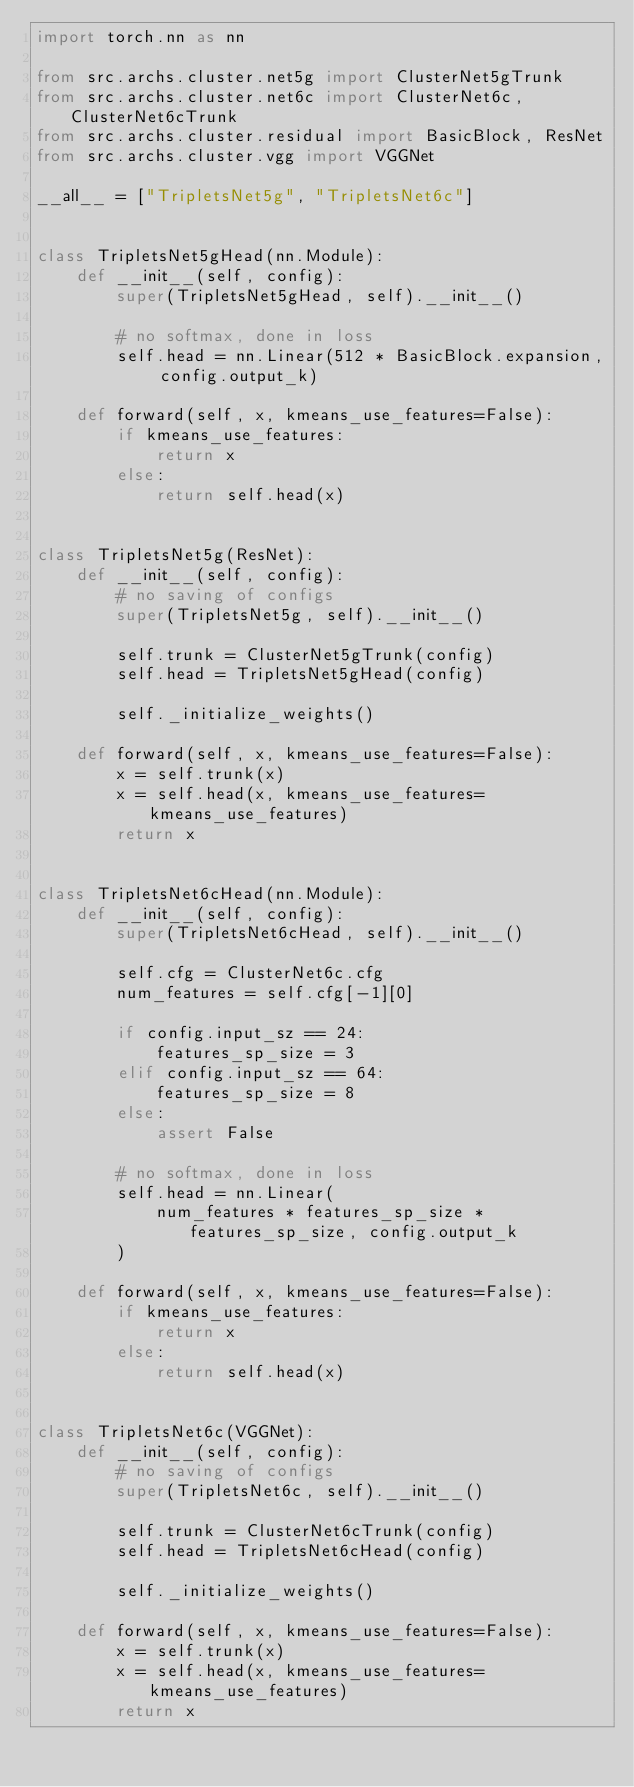Convert code to text. <code><loc_0><loc_0><loc_500><loc_500><_Python_>import torch.nn as nn

from src.archs.cluster.net5g import ClusterNet5gTrunk
from src.archs.cluster.net6c import ClusterNet6c, ClusterNet6cTrunk
from src.archs.cluster.residual import BasicBlock, ResNet
from src.archs.cluster.vgg import VGGNet

__all__ = ["TripletsNet5g", "TripletsNet6c"]


class TripletsNet5gHead(nn.Module):
    def __init__(self, config):
        super(TripletsNet5gHead, self).__init__()

        # no softmax, done in loss
        self.head = nn.Linear(512 * BasicBlock.expansion, config.output_k)

    def forward(self, x, kmeans_use_features=False):
        if kmeans_use_features:
            return x
        else:
            return self.head(x)


class TripletsNet5g(ResNet):
    def __init__(self, config):
        # no saving of configs
        super(TripletsNet5g, self).__init__()

        self.trunk = ClusterNet5gTrunk(config)
        self.head = TripletsNet5gHead(config)

        self._initialize_weights()

    def forward(self, x, kmeans_use_features=False):
        x = self.trunk(x)
        x = self.head(x, kmeans_use_features=kmeans_use_features)
        return x


class TripletsNet6cHead(nn.Module):
    def __init__(self, config):
        super(TripletsNet6cHead, self).__init__()

        self.cfg = ClusterNet6c.cfg
        num_features = self.cfg[-1][0]

        if config.input_sz == 24:
            features_sp_size = 3
        elif config.input_sz == 64:
            features_sp_size = 8
        else:
            assert False

        # no softmax, done in loss
        self.head = nn.Linear(
            num_features * features_sp_size * features_sp_size, config.output_k
        )

    def forward(self, x, kmeans_use_features=False):
        if kmeans_use_features:
            return x
        else:
            return self.head(x)


class TripletsNet6c(VGGNet):
    def __init__(self, config):
        # no saving of configs
        super(TripletsNet6c, self).__init__()

        self.trunk = ClusterNet6cTrunk(config)
        self.head = TripletsNet6cHead(config)

        self._initialize_weights()

    def forward(self, x, kmeans_use_features=False):
        x = self.trunk(x)
        x = self.head(x, kmeans_use_features=kmeans_use_features)
        return x
</code> 